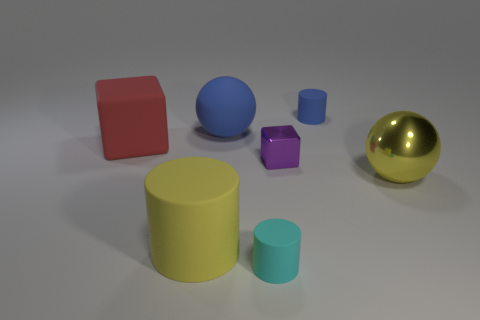Subtract all small rubber cylinders. How many cylinders are left? 1 Subtract all blue cylinders. How many cylinders are left? 2 Subtract all cyan cubes. How many yellow spheres are left? 1 Subtract all yellow cylinders. Subtract all matte objects. How many objects are left? 1 Add 1 large yellow shiny objects. How many large yellow shiny objects are left? 2 Add 6 large cyan rubber cylinders. How many large cyan rubber cylinders exist? 6 Add 1 large brown metal cylinders. How many objects exist? 8 Subtract 0 gray balls. How many objects are left? 7 Subtract all balls. How many objects are left? 5 Subtract 1 blocks. How many blocks are left? 1 